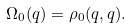<formula> <loc_0><loc_0><loc_500><loc_500>\Omega _ { 0 } ( q ) = \rho _ { 0 } ( q , q ) .</formula> 